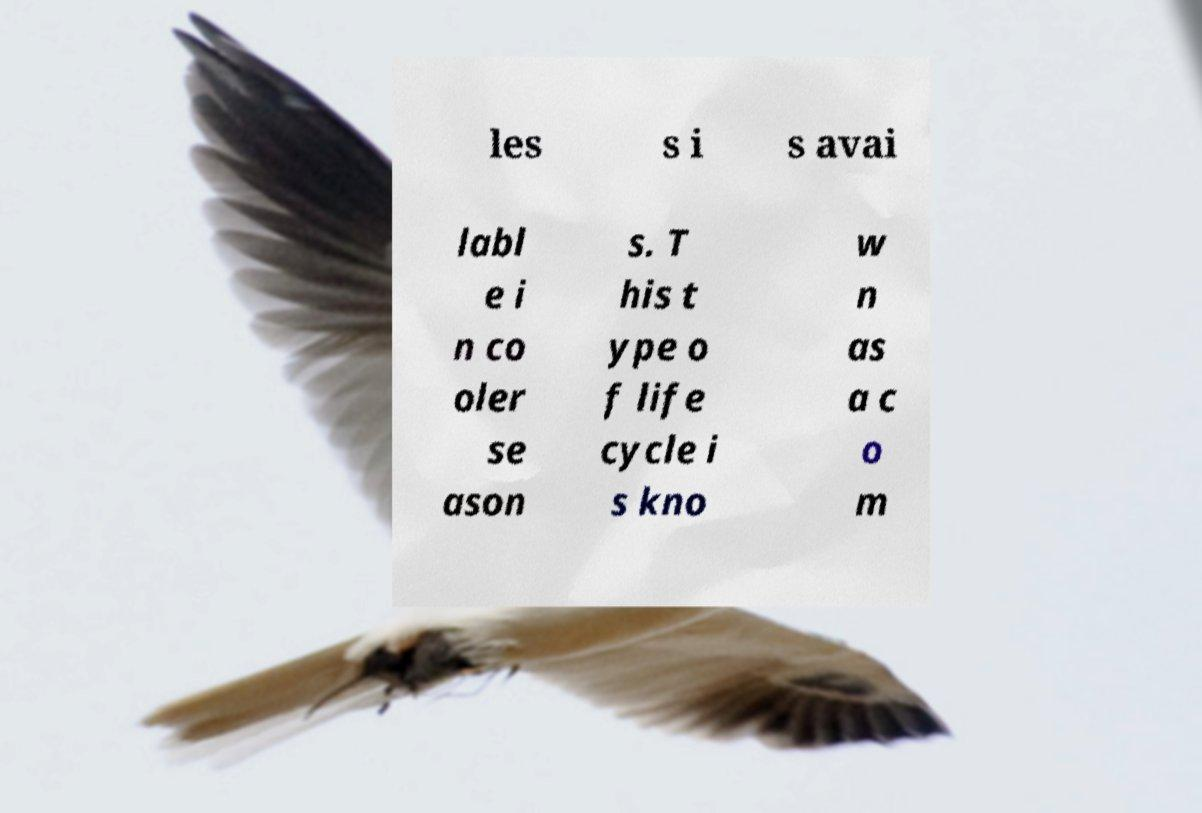What messages or text are displayed in this image? I need them in a readable, typed format. les s i s avai labl e i n co oler se ason s. T his t ype o f life cycle i s kno w n as a c o m 